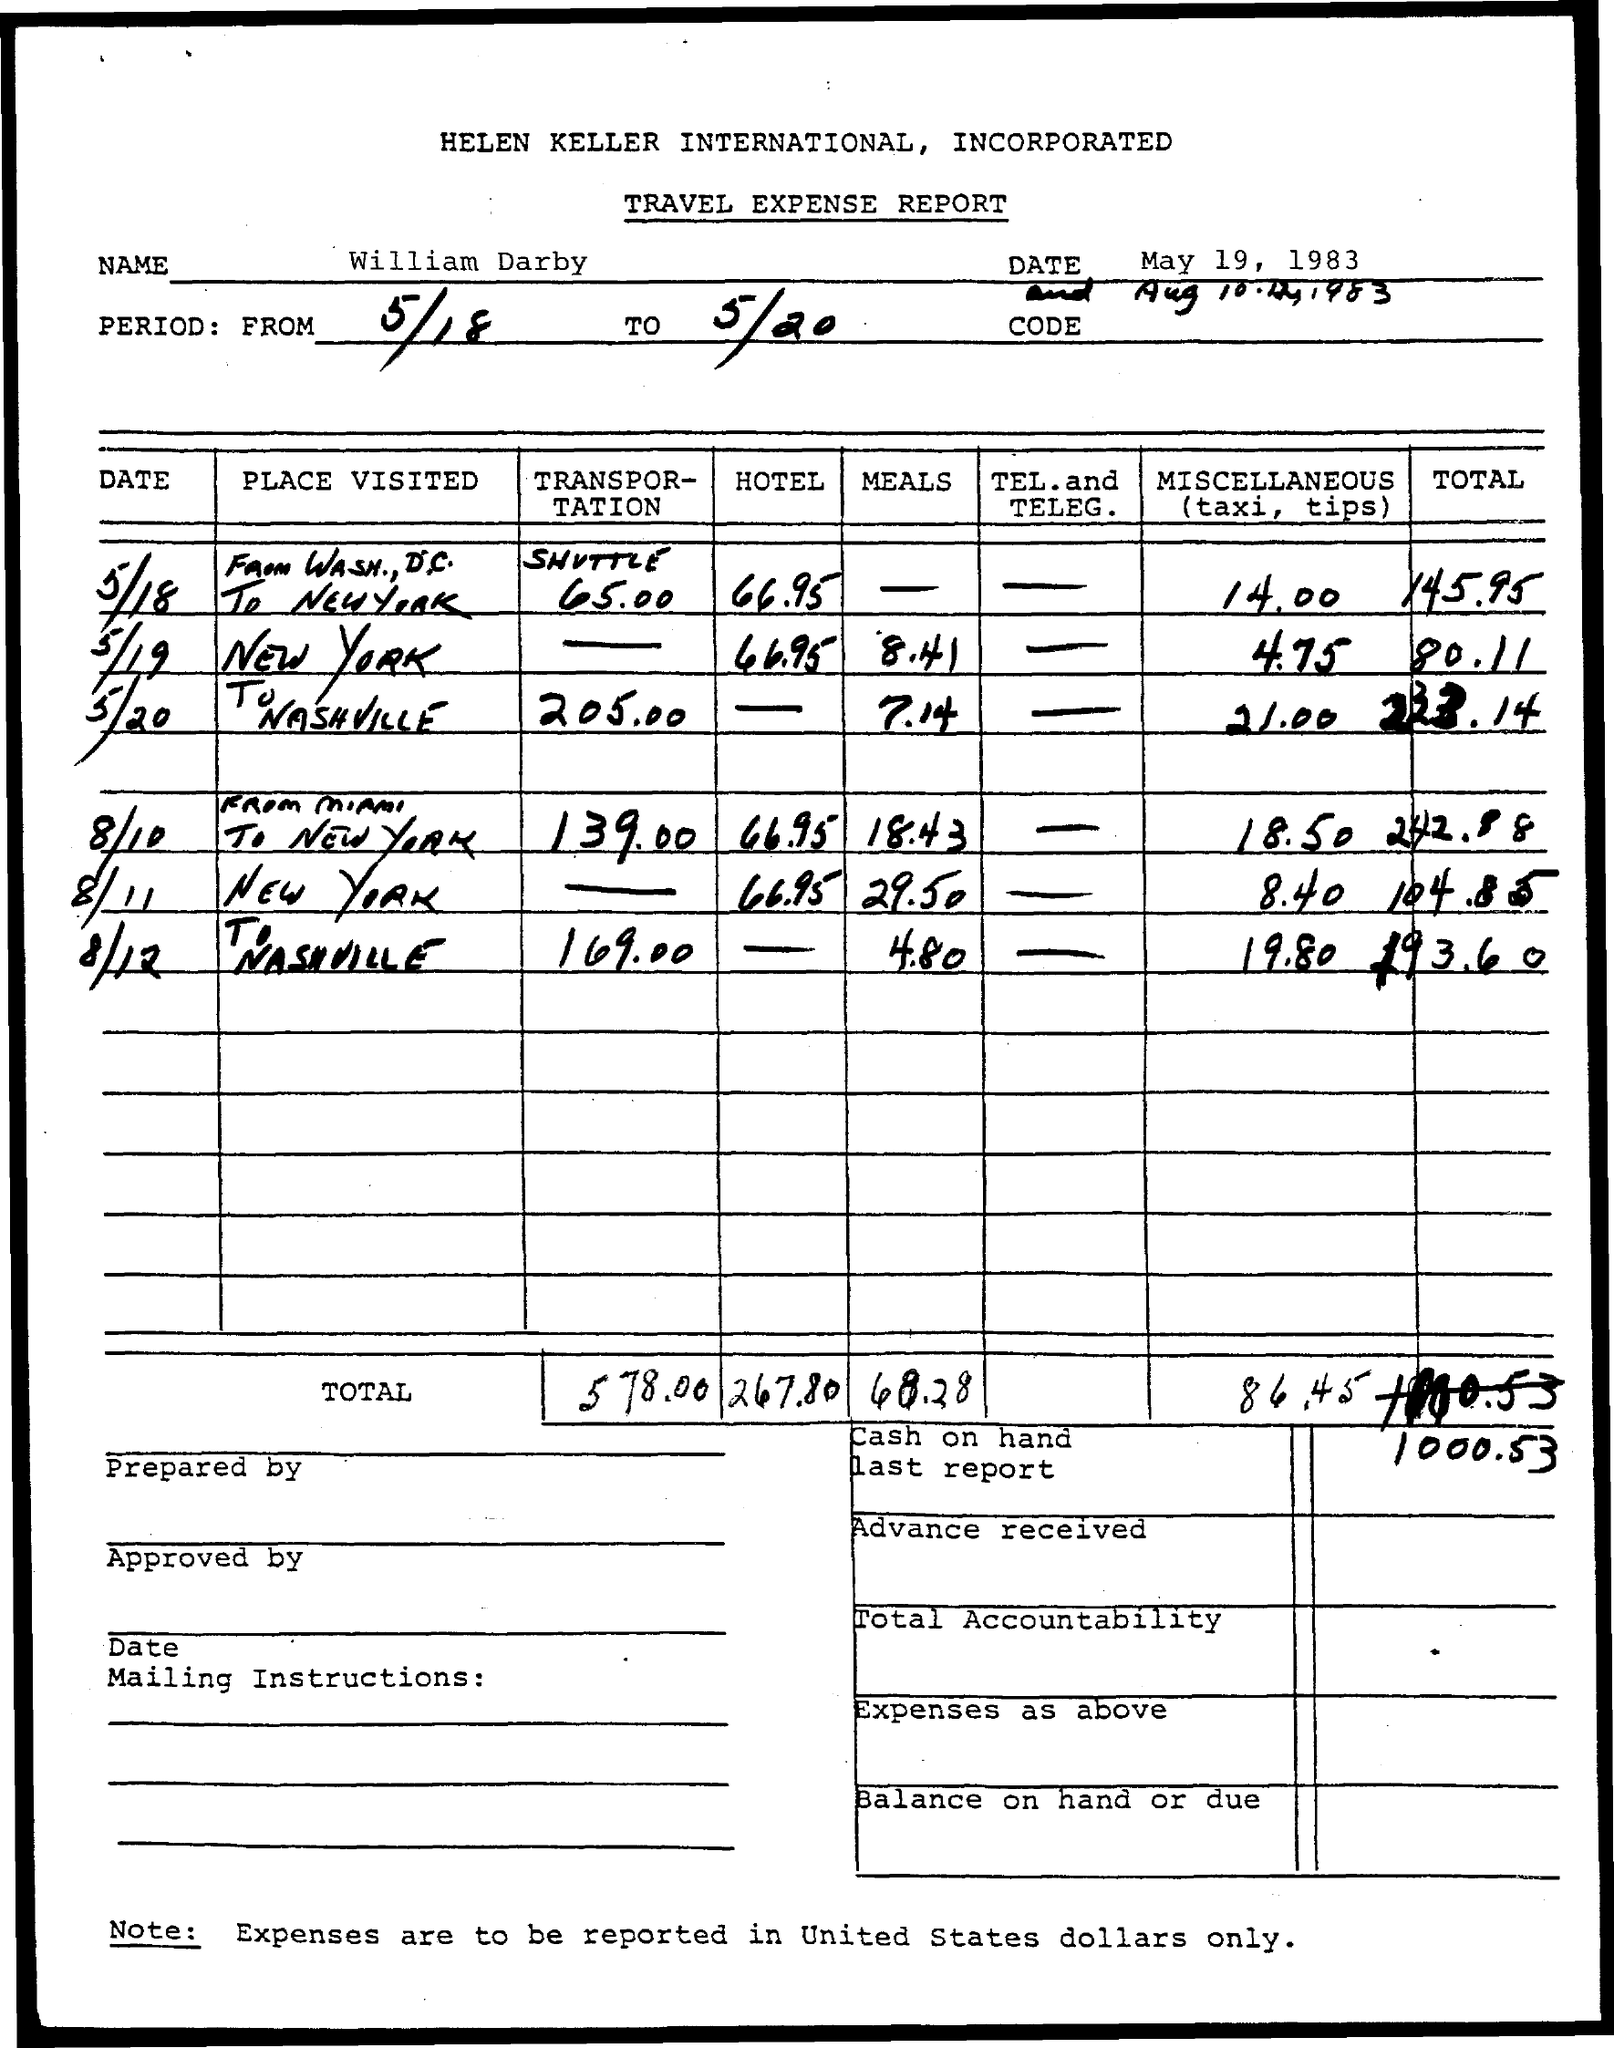Mention a couple of crucial points in this snapshot. The name of the person mentioned in the document is William Darby. 